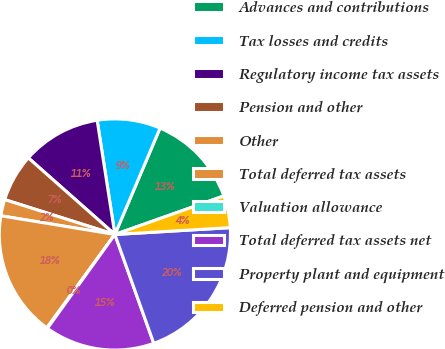Convert chart to OTSL. <chart><loc_0><loc_0><loc_500><loc_500><pie_chart><fcel>Advances and contributions<fcel>Tax losses and credits<fcel>Regulatory income tax assets<fcel>Pension and other<fcel>Other<fcel>Total deferred tax assets<fcel>Valuation allowance<fcel>Total deferred tax assets net<fcel>Property plant and equipment<fcel>Deferred pension and other<nl><fcel>13.2%<fcel>8.84%<fcel>11.02%<fcel>6.65%<fcel>2.29%<fcel>17.56%<fcel>0.11%<fcel>15.38%<fcel>20.48%<fcel>4.47%<nl></chart> 